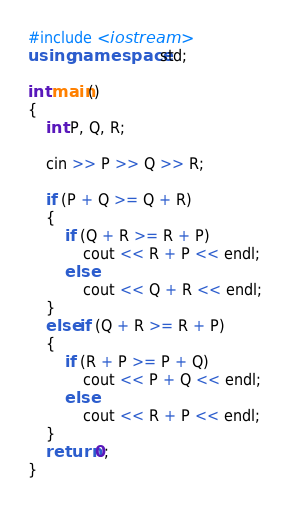Convert code to text. <code><loc_0><loc_0><loc_500><loc_500><_C++_>#include <iostream>
using namespace std;

int main()
{
    int P, Q, R;

    cin >> P >> Q >> R;

    if (P + Q >= Q + R)
    {
        if (Q + R >= R + P)
            cout << R + P << endl;
        else
            cout << Q + R << endl;
    }
    else if (Q + R >= R + P)
    {
        if (R + P >= P + Q)
            cout << P + Q << endl;
        else
            cout << R + P << endl;
    }
    return 0;
}</code> 